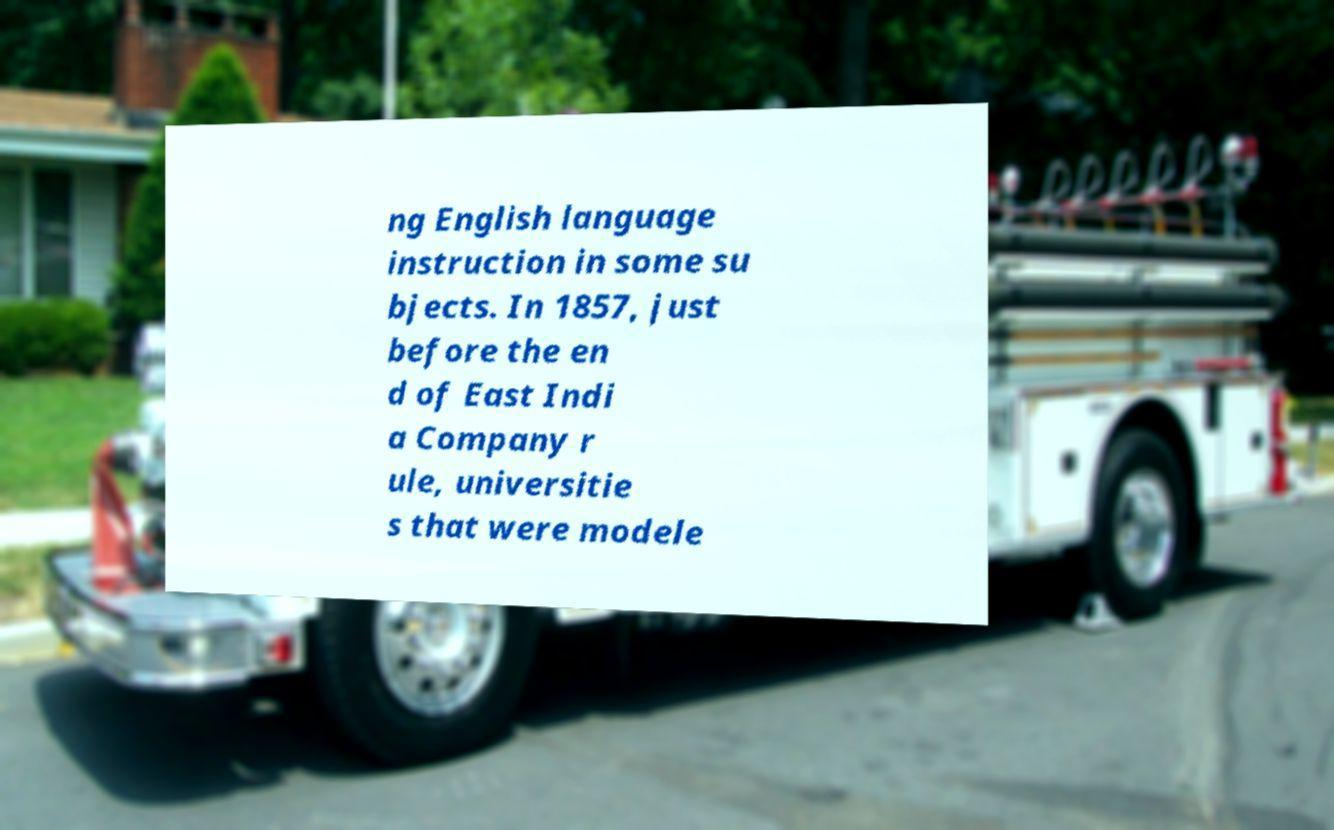Can you read and provide the text displayed in the image?This photo seems to have some interesting text. Can you extract and type it out for me? ng English language instruction in some su bjects. In 1857, just before the en d of East Indi a Company r ule, universitie s that were modele 